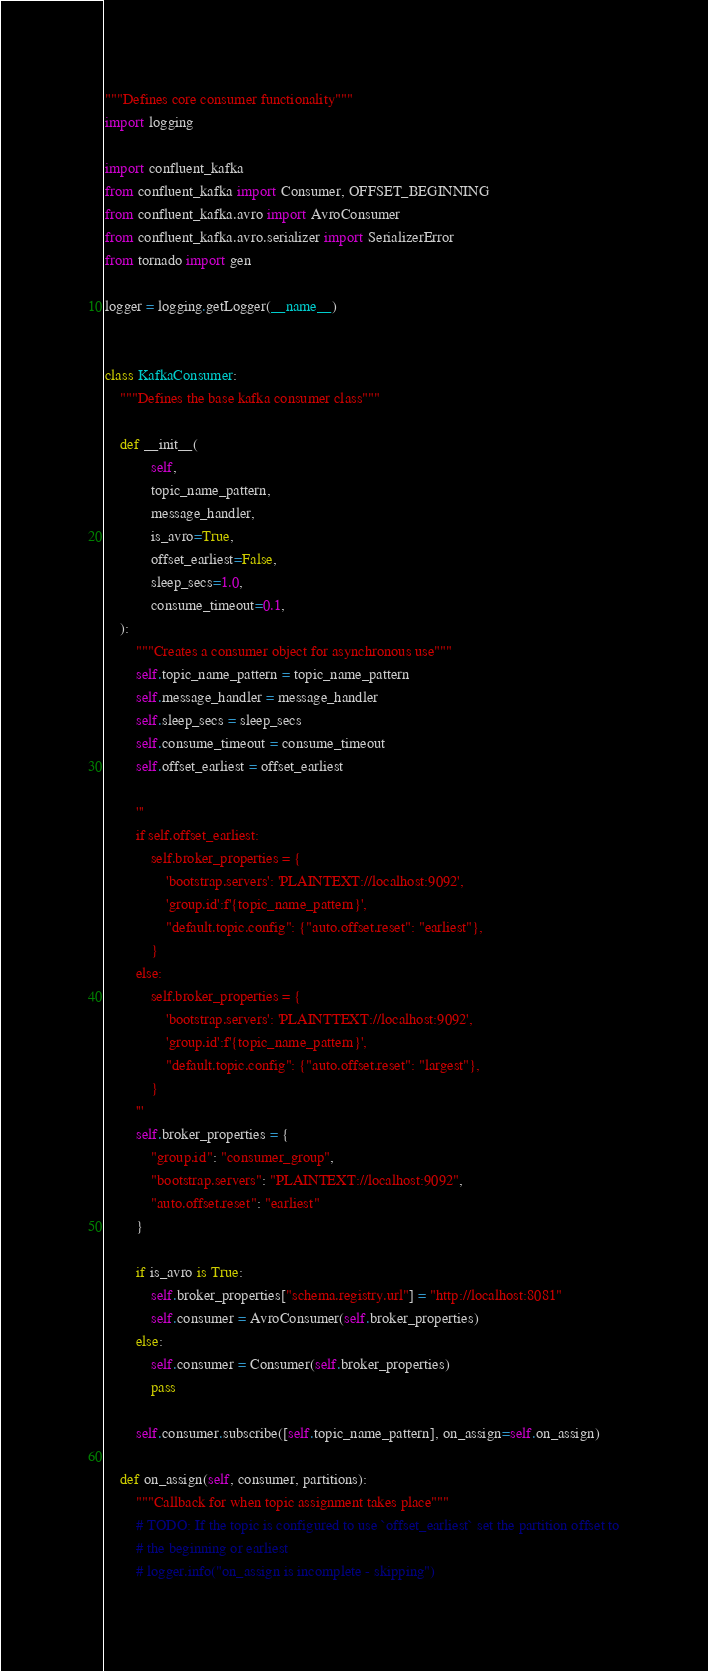<code> <loc_0><loc_0><loc_500><loc_500><_Python_>"""Defines core consumer functionality"""
import logging

import confluent_kafka
from confluent_kafka import Consumer, OFFSET_BEGINNING
from confluent_kafka.avro import AvroConsumer
from confluent_kafka.avro.serializer import SerializerError
from tornado import gen

logger = logging.getLogger(__name__)


class KafkaConsumer:
    """Defines the base kafka consumer class"""

    def __init__(
            self,
            topic_name_pattern,
            message_handler,
            is_avro=True,
            offset_earliest=False,
            sleep_secs=1.0,
            consume_timeout=0.1,
    ):
        """Creates a consumer object for asynchronous use"""
        self.topic_name_pattern = topic_name_pattern
        self.message_handler = message_handler
        self.sleep_secs = sleep_secs
        self.consume_timeout = consume_timeout
        self.offset_earliest = offset_earliest

        '''
        if self.offset_earliest:
            self.broker_properties = {
                'bootstrap.servers': 'PLAINTEXT://localhost:9092',
                'group.id':f'{topic_name_pattern}',
                "default.topic.config": {"auto.offset.reset": "earliest"},
            }
        else:
            self.broker_properties = {
                'bootstrap.servers': 'PLAINTTEXT://localhost:9092',
                'group.id':f'{topic_name_pattern}',
                "default.topic.config": {"auto.offset.reset": "largest"},
            }
        '''
        self.broker_properties = {
            "group.id": "consumer_group",
            "bootstrap.servers": "PLAINTEXT://localhost:9092",
            "auto.offset.reset": "earliest"
        }

        if is_avro is True:
            self.broker_properties["schema.registry.url"] = "http://localhost:8081"
            self.consumer = AvroConsumer(self.broker_properties)
        else:
            self.consumer = Consumer(self.broker_properties)
            pass

        self.consumer.subscribe([self.topic_name_pattern], on_assign=self.on_assign)

    def on_assign(self, consumer, partitions):
        """Callback for when topic assignment takes place"""
        # TODO: If the topic is configured to use `offset_earliest` set the partition offset to
        # the beginning or earliest
        # logger.info("on_assign is incomplete - skipping")</code> 